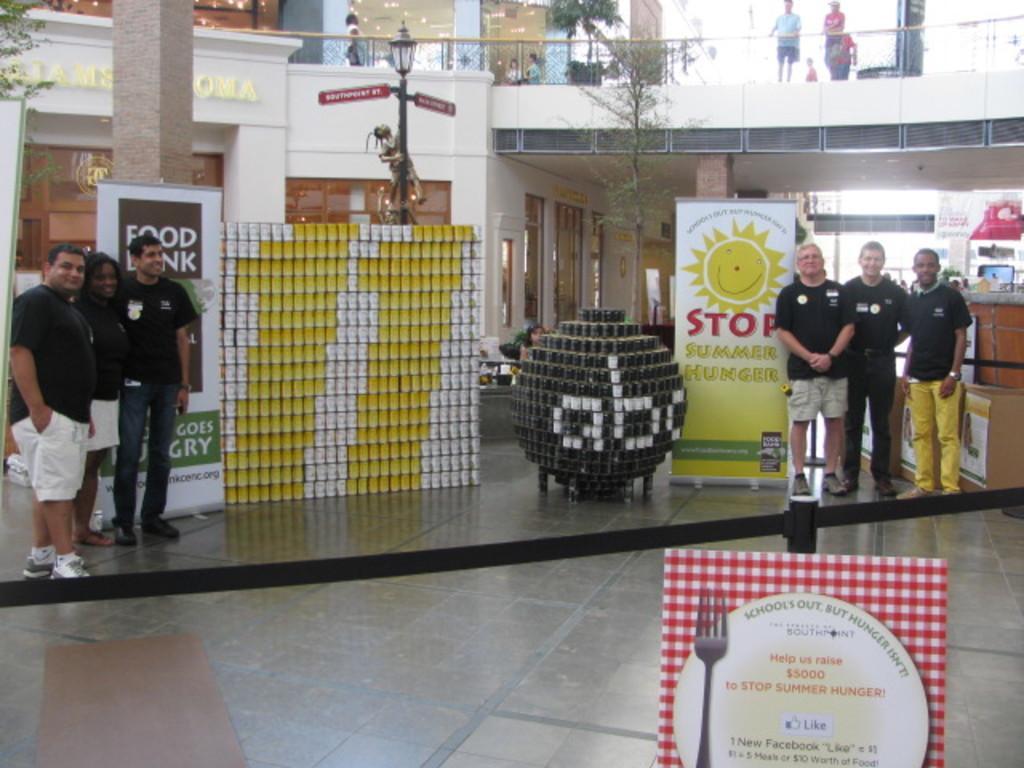How would you summarize this image in a sentence or two? On the left there are three person standing near to the banner. On the right there are three man was standing near to the banner and cotton boxes. On the top we can see two person standing near to the fencing. Here we can see a girl who is standing behind this black object. Here we can see a statue which is on the street light. On the top there is a plant. 